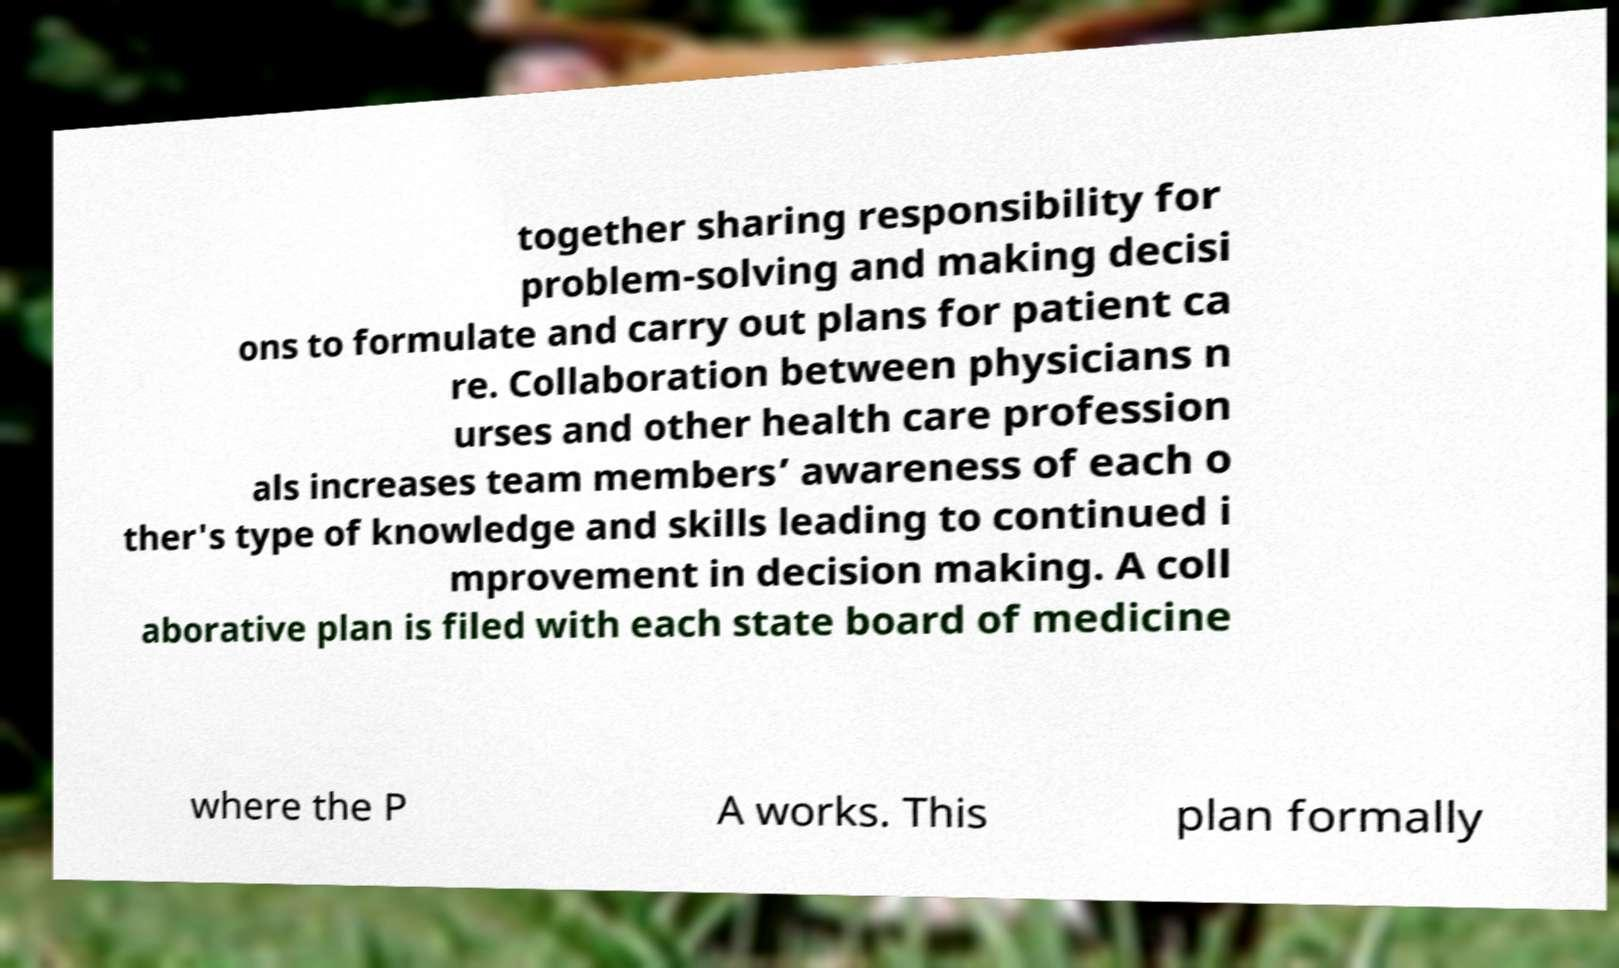Can you accurately transcribe the text from the provided image for me? together sharing responsibility for problem-solving and making decisi ons to formulate and carry out plans for patient ca re. Collaboration between physicians n urses and other health care profession als increases team members’ awareness of each o ther's type of knowledge and skills leading to continued i mprovement in decision making. A coll aborative plan is filed with each state board of medicine where the P A works. This plan formally 